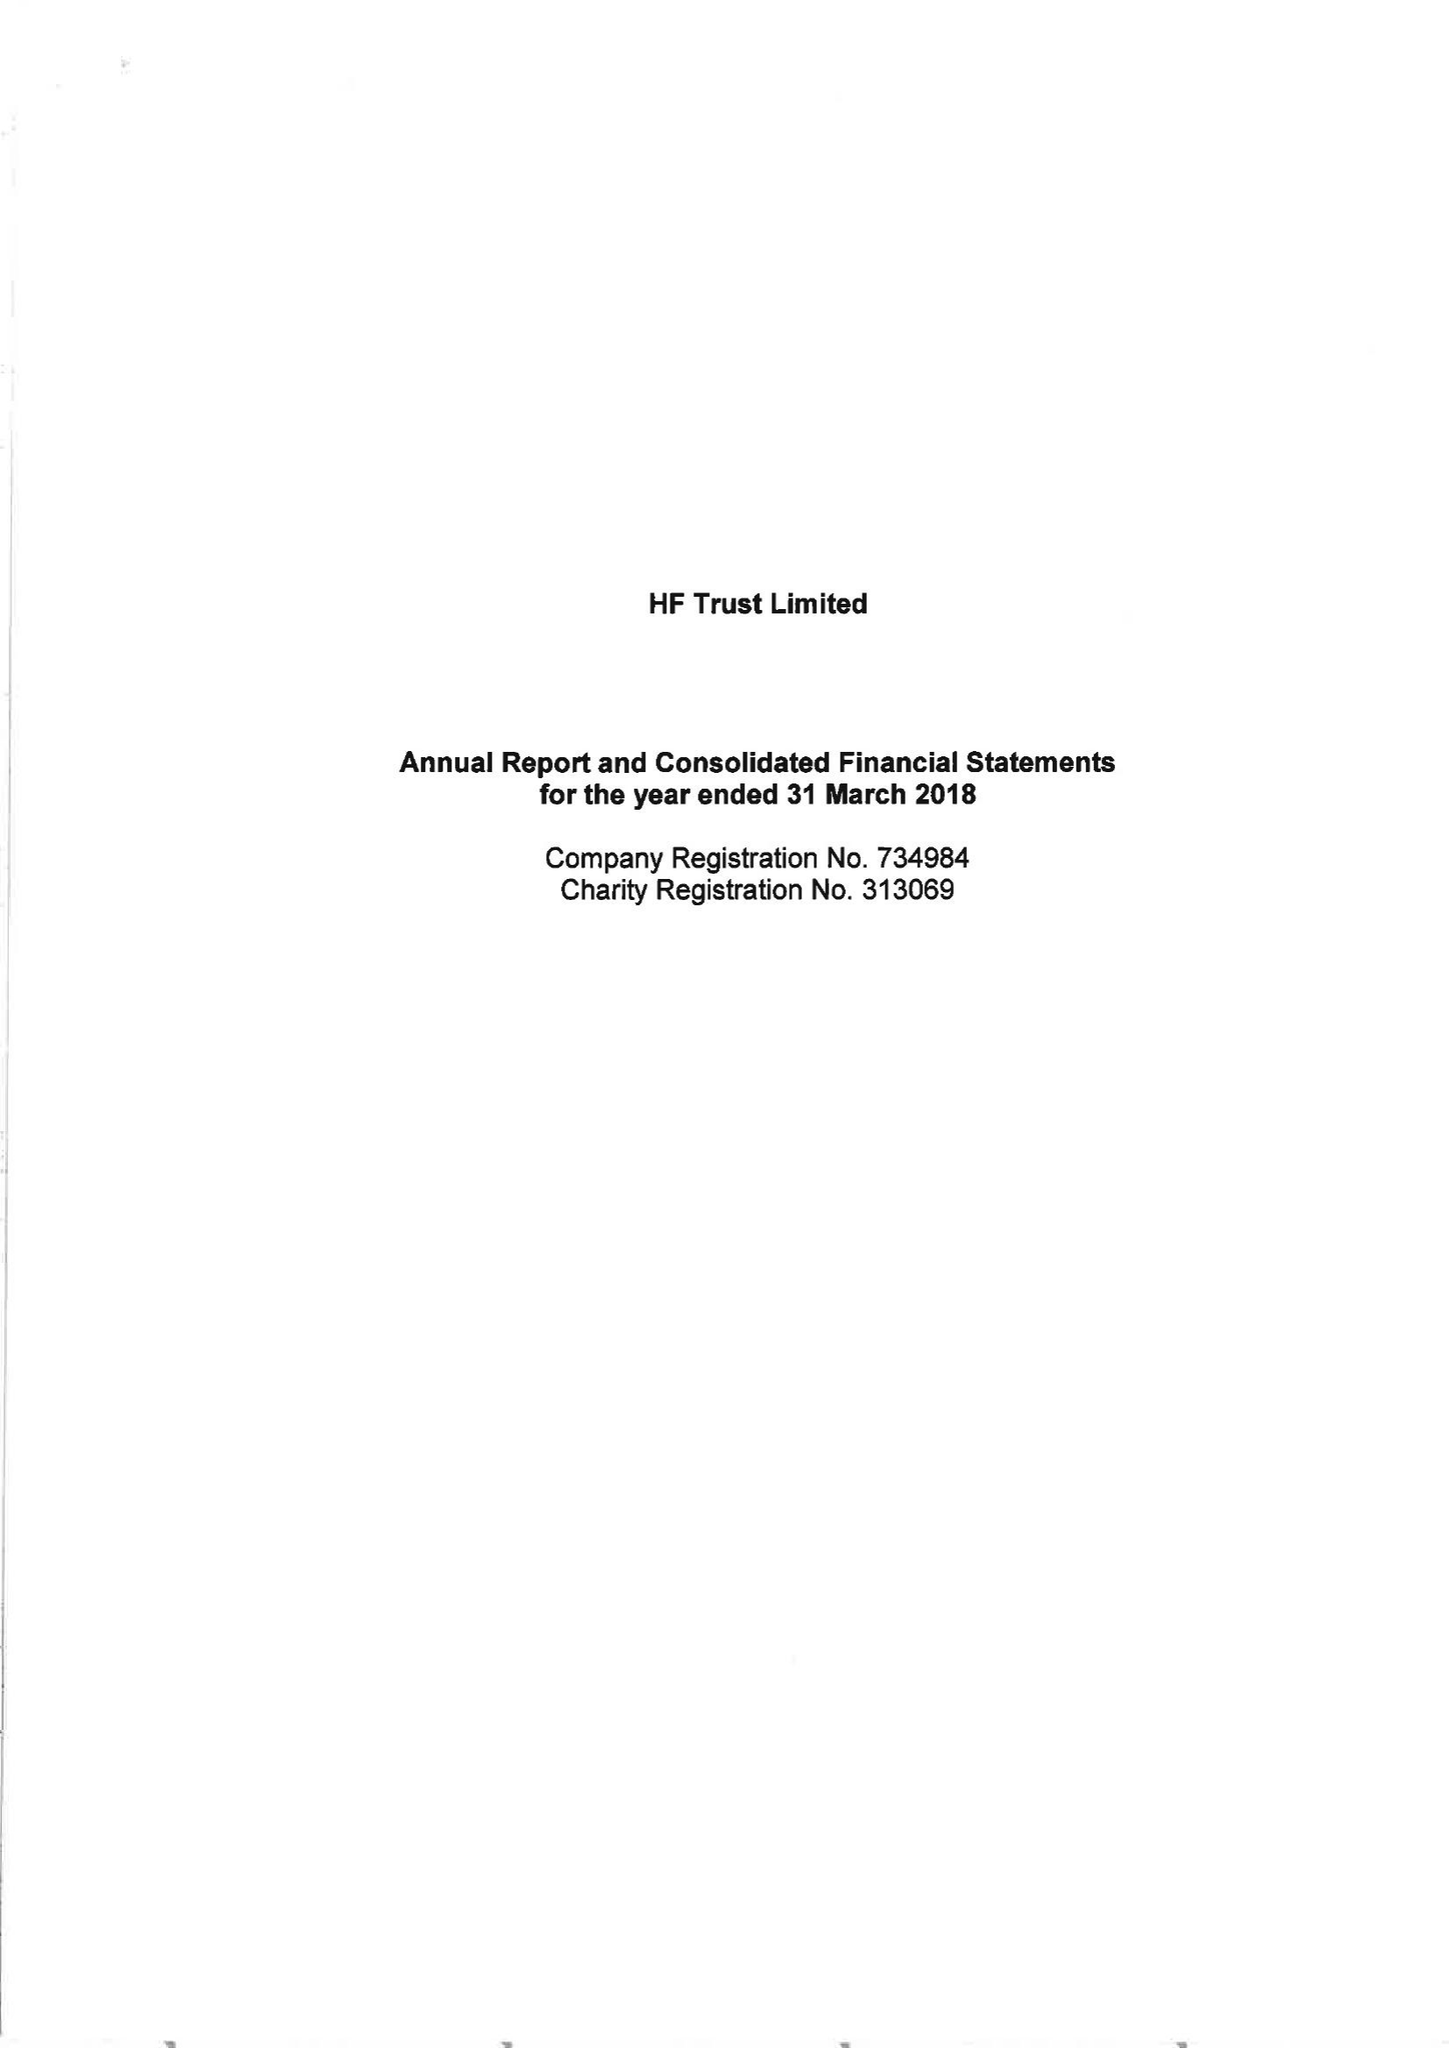What is the value for the charity_name?
Answer the question using a single word or phrase. Hf Trust Ltd. 